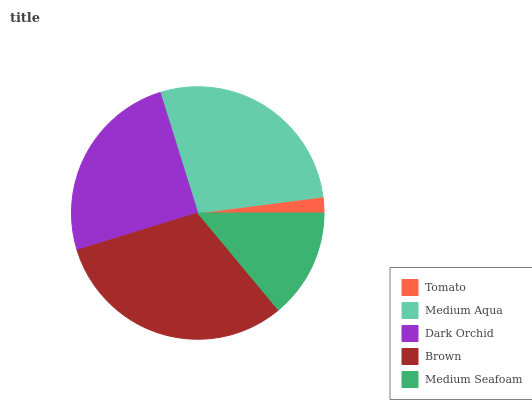Is Tomato the minimum?
Answer yes or no. Yes. Is Brown the maximum?
Answer yes or no. Yes. Is Medium Aqua the minimum?
Answer yes or no. No. Is Medium Aqua the maximum?
Answer yes or no. No. Is Medium Aqua greater than Tomato?
Answer yes or no. Yes. Is Tomato less than Medium Aqua?
Answer yes or no. Yes. Is Tomato greater than Medium Aqua?
Answer yes or no. No. Is Medium Aqua less than Tomato?
Answer yes or no. No. Is Dark Orchid the high median?
Answer yes or no. Yes. Is Dark Orchid the low median?
Answer yes or no. Yes. Is Brown the high median?
Answer yes or no. No. Is Brown the low median?
Answer yes or no. No. 